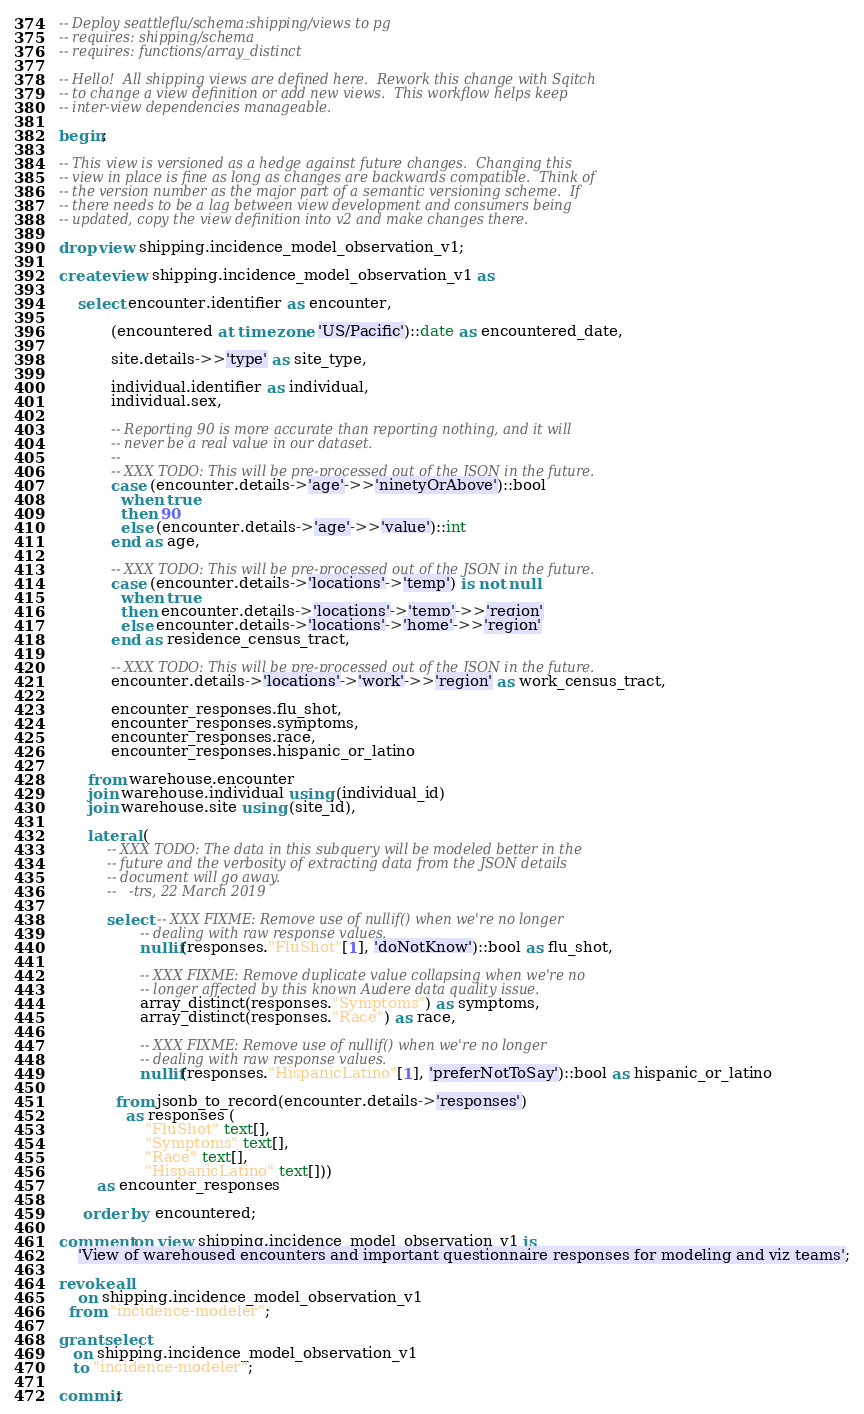<code> <loc_0><loc_0><loc_500><loc_500><_SQL_>-- Deploy seattleflu/schema:shipping/views to pg
-- requires: shipping/schema
-- requires: functions/array_distinct

-- Hello!  All shipping views are defined here.  Rework this change with Sqitch
-- to change a view definition or add new views.  This workflow helps keep
-- inter-view dependencies manageable.

begin;

-- This view is versioned as a hedge against future changes.  Changing this
-- view in place is fine as long as changes are backwards compatible.  Think of
-- the version number as the major part of a semantic versioning scheme.  If
-- there needs to be a lag between view development and consumers being
-- updated, copy the view definition into v2 and make changes there.

drop view shipping.incidence_model_observation_v1;

create view shipping.incidence_model_observation_v1 as

    select encounter.identifier as encounter,

           (encountered at time zone 'US/Pacific')::date as encountered_date,

           site.details->>'type' as site_type,

           individual.identifier as individual,
           individual.sex,

           -- Reporting 90 is more accurate than reporting nothing, and it will
           -- never be a real value in our dataset.
           --
           -- XXX TODO: This will be pre-processed out of the JSON in the future.
           case (encounter.details->'age'->>'ninetyOrAbove')::bool
             when true
             then 90
             else (encounter.details->'age'->>'value')::int
           end as age,

           -- XXX TODO: This will be pre-processed out of the JSON in the future.
           case (encounter.details->'locations'->'temp') is not null
             when true
             then encounter.details->'locations'->'temp'->>'region'
             else encounter.details->'locations'->'home'->>'region'
           end as residence_census_tract,

           -- XXX TODO: This will be pre-processed out of the JSON in the future.
           encounter.details->'locations'->'work'->>'region' as work_census_tract,

           encounter_responses.flu_shot,
           encounter_responses.symptoms,
           encounter_responses.race,
           encounter_responses.hispanic_or_latino

      from warehouse.encounter
      join warehouse.individual using (individual_id)
      join warehouse.site using (site_id),

      lateral (
          -- XXX TODO: The data in this subquery will be modeled better in the
          -- future and the verbosity of extracting data from the JSON details
          -- document will go away.
          --   -trs, 22 March 2019

          select -- XXX FIXME: Remove use of nullif() when we're no longer
                 -- dealing with raw response values.
                 nullif(responses."FluShot"[1], 'doNotKnow')::bool as flu_shot,

                 -- XXX FIXME: Remove duplicate value collapsing when we're no
                 -- longer affected by this known Audere data quality issue.
                 array_distinct(responses."Symptoms") as symptoms,
                 array_distinct(responses."Race") as race,

                 -- XXX FIXME: Remove use of nullif() when we're no longer
                 -- dealing with raw response values.
                 nullif(responses."HispanicLatino"[1], 'preferNotToSay')::bool as hispanic_or_latino

            from jsonb_to_record(encounter.details->'responses')
              as responses (
                  "FluShot" text[],
                  "Symptoms" text[],
                  "Race" text[],
                  "HispanicLatino" text[]))
        as encounter_responses

     order by encountered;

comment on view shipping.incidence_model_observation_v1 is
    'View of warehoused encounters and important questionnaire responses for modeling and viz teams';

revoke all
    on shipping.incidence_model_observation_v1
  from "incidence-modeler";

grant select
   on shipping.incidence_model_observation_v1
   to "incidence-modeler";

commit;
</code> 